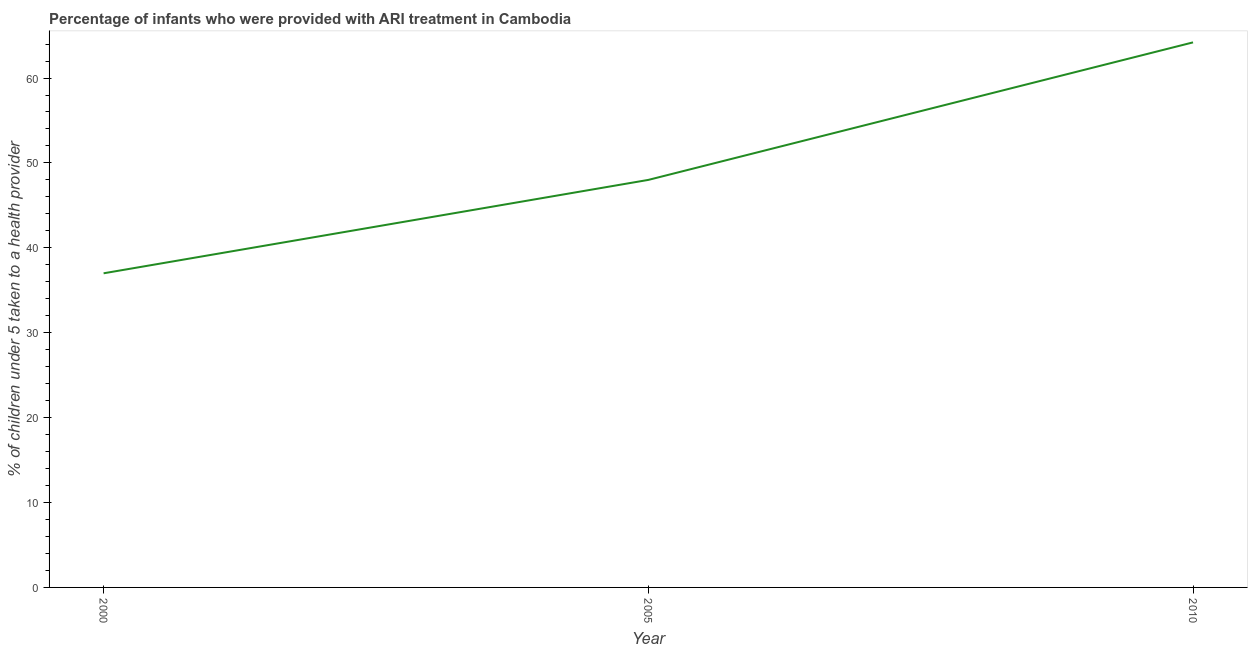Across all years, what is the maximum percentage of children who were provided with ari treatment?
Offer a very short reply. 64.2. In which year was the percentage of children who were provided with ari treatment maximum?
Your response must be concise. 2010. In which year was the percentage of children who were provided with ari treatment minimum?
Keep it short and to the point. 2000. What is the sum of the percentage of children who were provided with ari treatment?
Keep it short and to the point. 149.2. What is the difference between the percentage of children who were provided with ari treatment in 2005 and 2010?
Give a very brief answer. -16.2. What is the average percentage of children who were provided with ari treatment per year?
Your response must be concise. 49.73. Do a majority of the years between 2010 and 2000 (inclusive) have percentage of children who were provided with ari treatment greater than 38 %?
Make the answer very short. No. What is the ratio of the percentage of children who were provided with ari treatment in 2005 to that in 2010?
Provide a short and direct response. 0.75. Is the percentage of children who were provided with ari treatment in 2000 less than that in 2005?
Offer a very short reply. Yes. What is the difference between the highest and the second highest percentage of children who were provided with ari treatment?
Keep it short and to the point. 16.2. What is the difference between the highest and the lowest percentage of children who were provided with ari treatment?
Your answer should be very brief. 27.2. In how many years, is the percentage of children who were provided with ari treatment greater than the average percentage of children who were provided with ari treatment taken over all years?
Your answer should be compact. 1. How many lines are there?
Offer a terse response. 1. Are the values on the major ticks of Y-axis written in scientific E-notation?
Provide a succinct answer. No. What is the title of the graph?
Provide a succinct answer. Percentage of infants who were provided with ARI treatment in Cambodia. What is the label or title of the X-axis?
Provide a short and direct response. Year. What is the label or title of the Y-axis?
Make the answer very short. % of children under 5 taken to a health provider. What is the % of children under 5 taken to a health provider in 2010?
Your answer should be very brief. 64.2. What is the difference between the % of children under 5 taken to a health provider in 2000 and 2010?
Keep it short and to the point. -27.2. What is the difference between the % of children under 5 taken to a health provider in 2005 and 2010?
Provide a succinct answer. -16.2. What is the ratio of the % of children under 5 taken to a health provider in 2000 to that in 2005?
Provide a succinct answer. 0.77. What is the ratio of the % of children under 5 taken to a health provider in 2000 to that in 2010?
Provide a short and direct response. 0.58. What is the ratio of the % of children under 5 taken to a health provider in 2005 to that in 2010?
Ensure brevity in your answer.  0.75. 